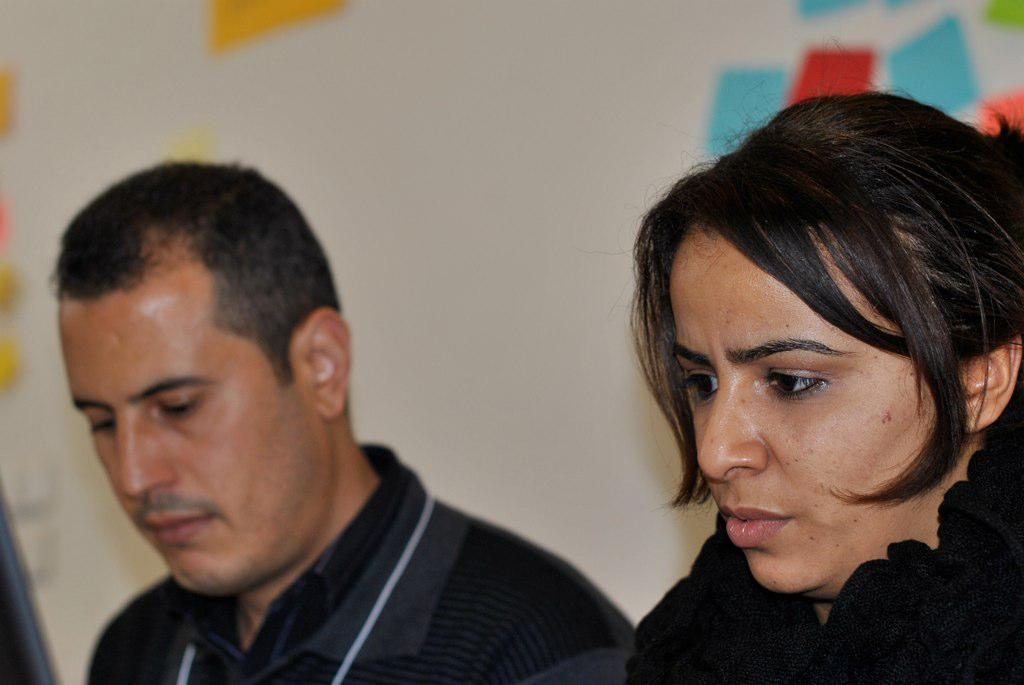Who are the people in the image? There is a man and a lady in the image. What can be seen in the background of the image? There is a wall in the background of the image. What type of pest can be seen crawling on the wall in the image? There are no pests visible in the image; only the man, the lady, and the wall are present. Can you tell me how many ducks are swimming in the water near the wall in the image? There is no water or ducks present in the image; it only features a man, a lady, and a wall. 